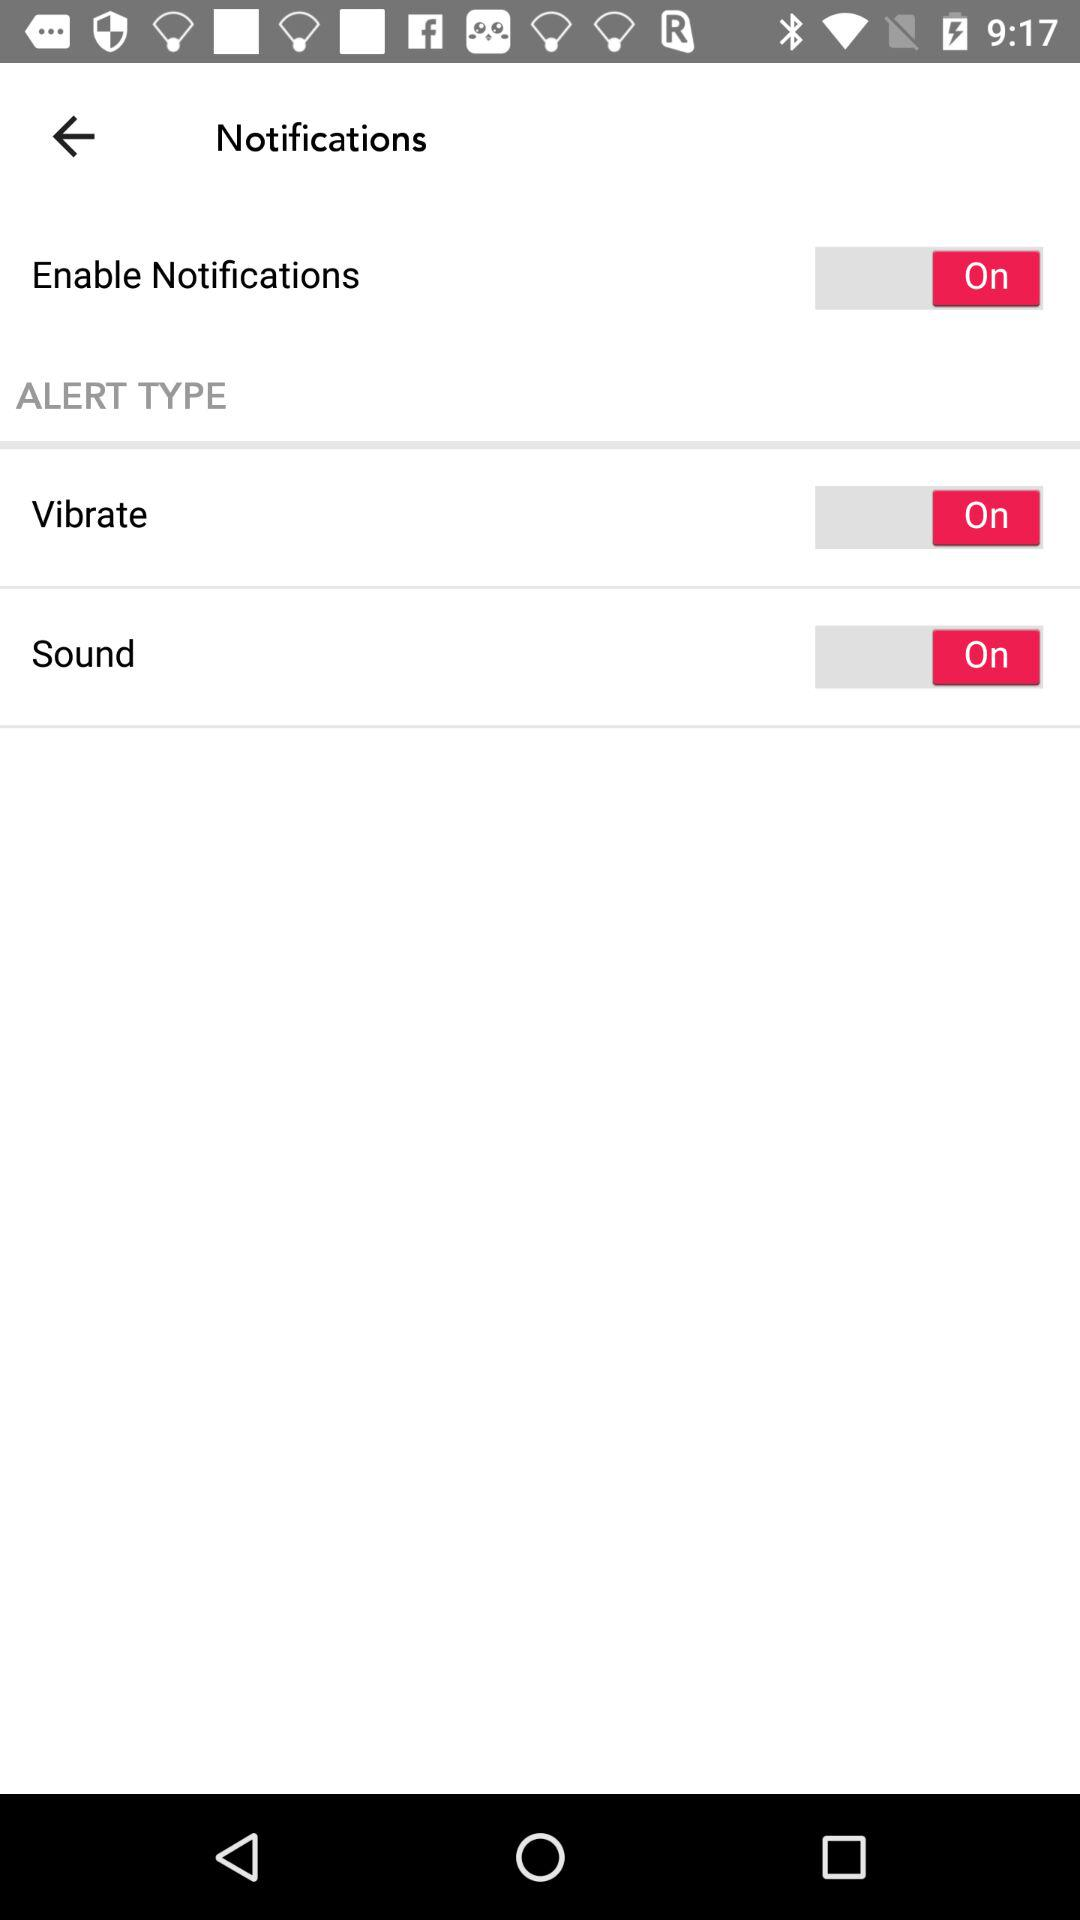What is the status of vibrating a phone? The status is "on". 